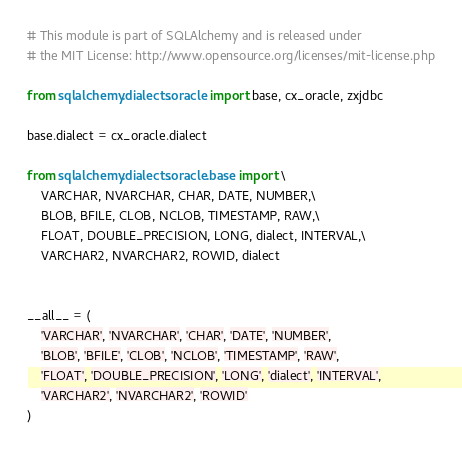Convert code to text. <code><loc_0><loc_0><loc_500><loc_500><_Python_># This module is part of SQLAlchemy and is released under
# the MIT License: http://www.opensource.org/licenses/mit-license.php

from sqlalchemy.dialects.oracle import base, cx_oracle, zxjdbc

base.dialect = cx_oracle.dialect

from sqlalchemy.dialects.oracle.base import \
    VARCHAR, NVARCHAR, CHAR, DATE, NUMBER,\
    BLOB, BFILE, CLOB, NCLOB, TIMESTAMP, RAW,\
    FLOAT, DOUBLE_PRECISION, LONG, dialect, INTERVAL,\
    VARCHAR2, NVARCHAR2, ROWID, dialect


__all__ = (
    'VARCHAR', 'NVARCHAR', 'CHAR', 'DATE', 'NUMBER',
    'BLOB', 'BFILE', 'CLOB', 'NCLOB', 'TIMESTAMP', 'RAW',
    'FLOAT', 'DOUBLE_PRECISION', 'LONG', 'dialect', 'INTERVAL',
    'VARCHAR2', 'NVARCHAR2', 'ROWID'
)
</code> 